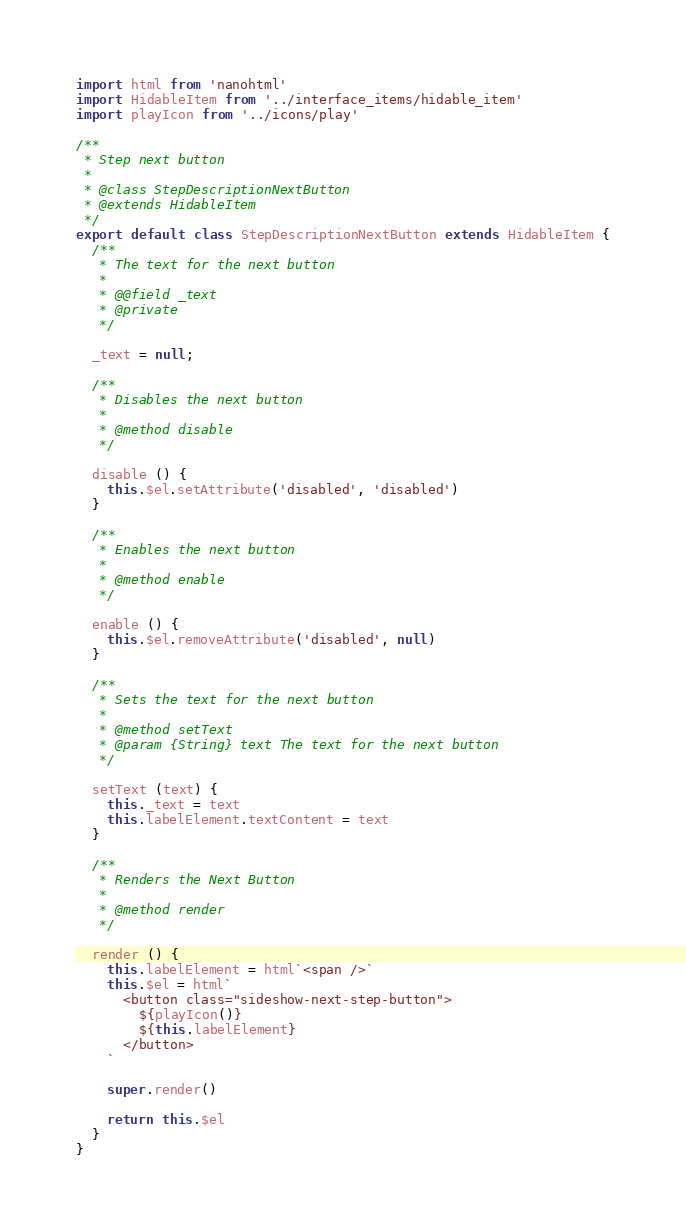<code> <loc_0><loc_0><loc_500><loc_500><_JavaScript_>import html from 'nanohtml'
import HidableItem from '../interface_items/hidable_item'
import playIcon from '../icons/play'

/**
 * Step next button
 *
 * @class StepDescriptionNextButton
 * @extends HidableItem
 */
export default class StepDescriptionNextButton extends HidableItem {
  /**
   * The text for the next button
   *
   * @@field _text
   * @private
   */

  _text = null;

  /**
   * Disables the next button
   *
   * @method disable
   */

  disable () {
    this.$el.setAttribute('disabled', 'disabled')
  }

  /**
   * Enables the next button
   *
   * @method enable
   */

  enable () {
    this.$el.removeAttribute('disabled', null)
  }

  /**
   * Sets the text for the next button
   *
   * @method setText
   * @param {String} text The text for the next button
   */

  setText (text) {
    this._text = text
    this.labelElement.textContent = text
  }

  /**
   * Renders the Next Button
   *
   * @method render
   */

  render () {
    this.labelElement = html`<span />`
    this.$el = html`
      <button class="sideshow-next-step-button">
        ${playIcon()}
        ${this.labelElement}
      </button>
    `

    super.render()

    return this.$el
  }
}
</code> 